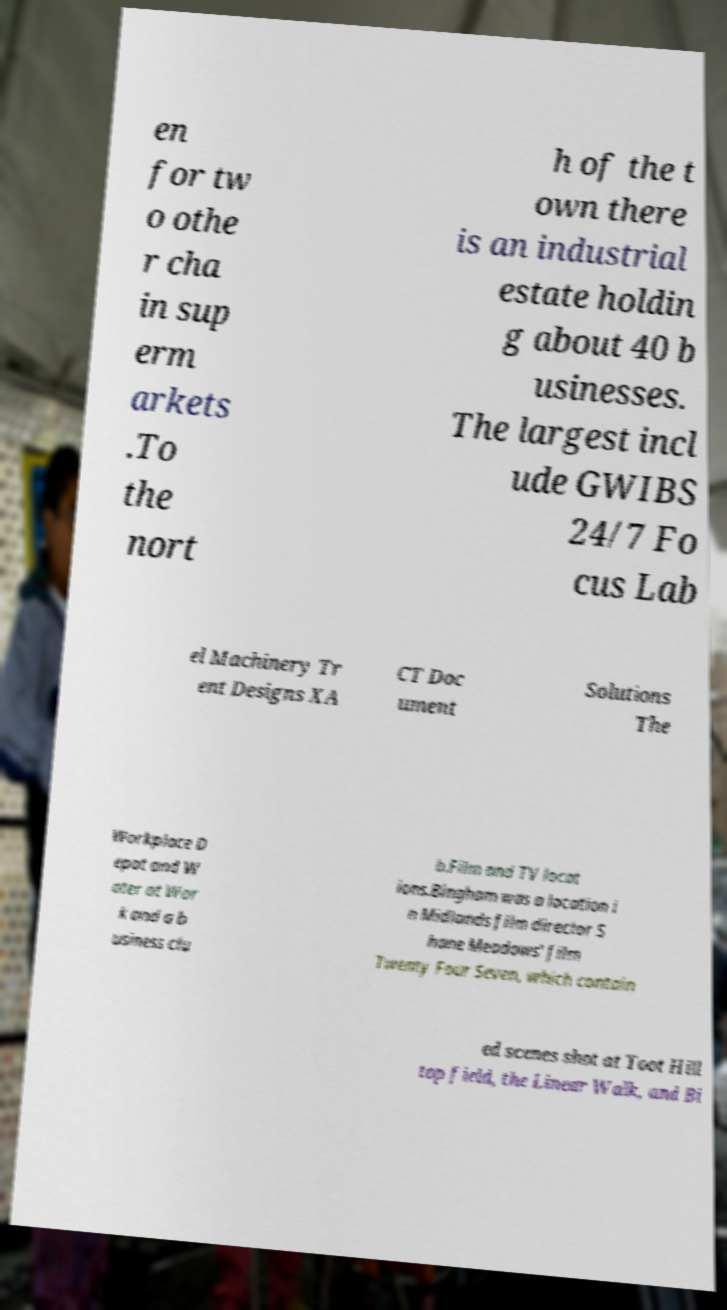For documentation purposes, I need the text within this image transcribed. Could you provide that? en for tw o othe r cha in sup erm arkets .To the nort h of the t own there is an industrial estate holdin g about 40 b usinesses. The largest incl ude GWIBS 24/7 Fo cus Lab el Machinery Tr ent Designs XA CT Doc ument Solutions The Workplace D epot and W ater at Wor k and a b usiness clu b.Film and TV locat ions.Bingham was a location i n Midlands film director S hane Meadows' film Twenty Four Seven, which contain ed scenes shot at Toot Hill top field, the Linear Walk, and Bi 